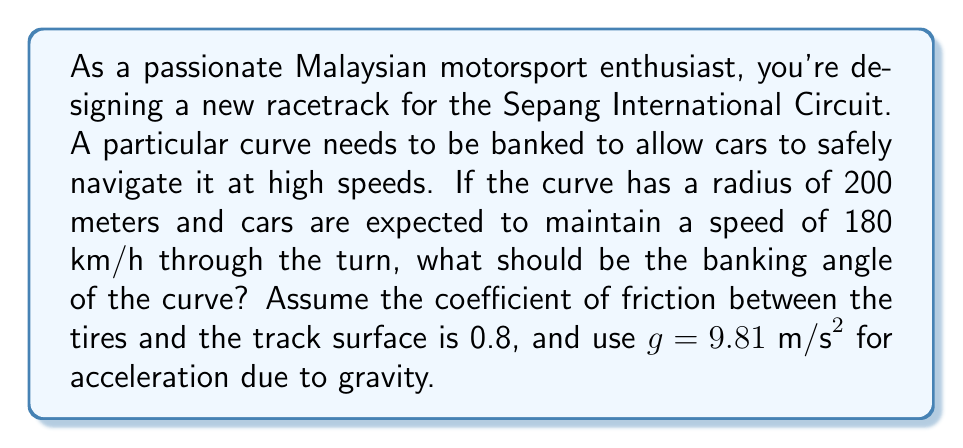Could you help me with this problem? To solve this problem, we'll use the formula for the banking angle of a curve:

$$\tan \theta = \frac{v^2}{rg} - \mu$$

Where:
$\theta$ = banking angle
$v$ = velocity of the car
$r$ = radius of the curve
$g$ = acceleration due to gravity
$\mu$ = coefficient of friction

Let's follow these steps:

1) First, convert the speed from km/h to m/s:
   $180 \text{ km/h} = 180 \times \frac{1000}{3600} = 50 \text{ m/s}$

2) Now, plug in all the values into the formula:
   $$\tan \theta = \frac{50^2}{200 \times 9.81} - 0.8$$

3) Simplify:
   $$\tan \theta = \frac{2500}{1962} - 0.8 = 1.2741 - 0.8 = 0.4741$$

4) To find $\theta$, we need to use the inverse tangent function:
   $$\theta = \tan^{-1}(0.4741)$$

5) Using a calculator or computer, we can evaluate this:
   $$\theta \approx 25.36^\circ$$

Therefore, the banking angle of the curve should be approximately 25.36°.
Answer: $25.36^\circ$ 